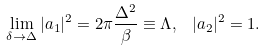<formula> <loc_0><loc_0><loc_500><loc_500>\lim _ { \delta \rightarrow \Delta } | a _ { 1 } | ^ { 2 } = 2 \pi \frac { \Delta ^ { 2 } } { \beta } \equiv \Lambda , \, \ | a _ { 2 } | ^ { 2 } = 1 .</formula> 